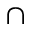<formula> <loc_0><loc_0><loc_500><loc_500>\cap</formula> 